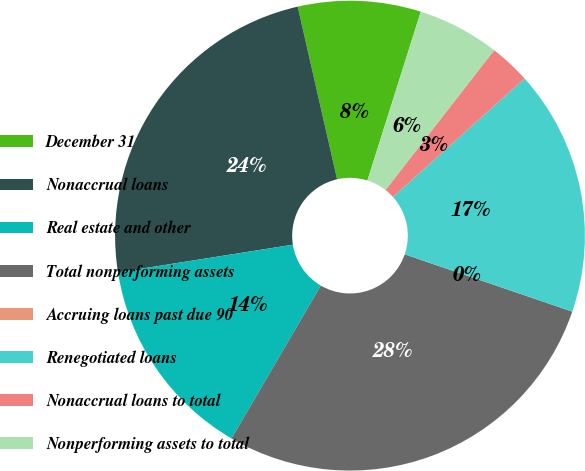Convert chart to OTSL. <chart><loc_0><loc_0><loc_500><loc_500><pie_chart><fcel>December 31<fcel>Nonaccrual loans<fcel>Real estate and other<fcel>Total nonperforming assets<fcel>Accruing loans past due 90<fcel>Renegotiated loans<fcel>Nonaccrual loans to total<fcel>Nonperforming assets to total<nl><fcel>8.45%<fcel>23.93%<fcel>14.09%<fcel>28.18%<fcel>0.0%<fcel>16.91%<fcel>2.82%<fcel>5.64%<nl></chart> 